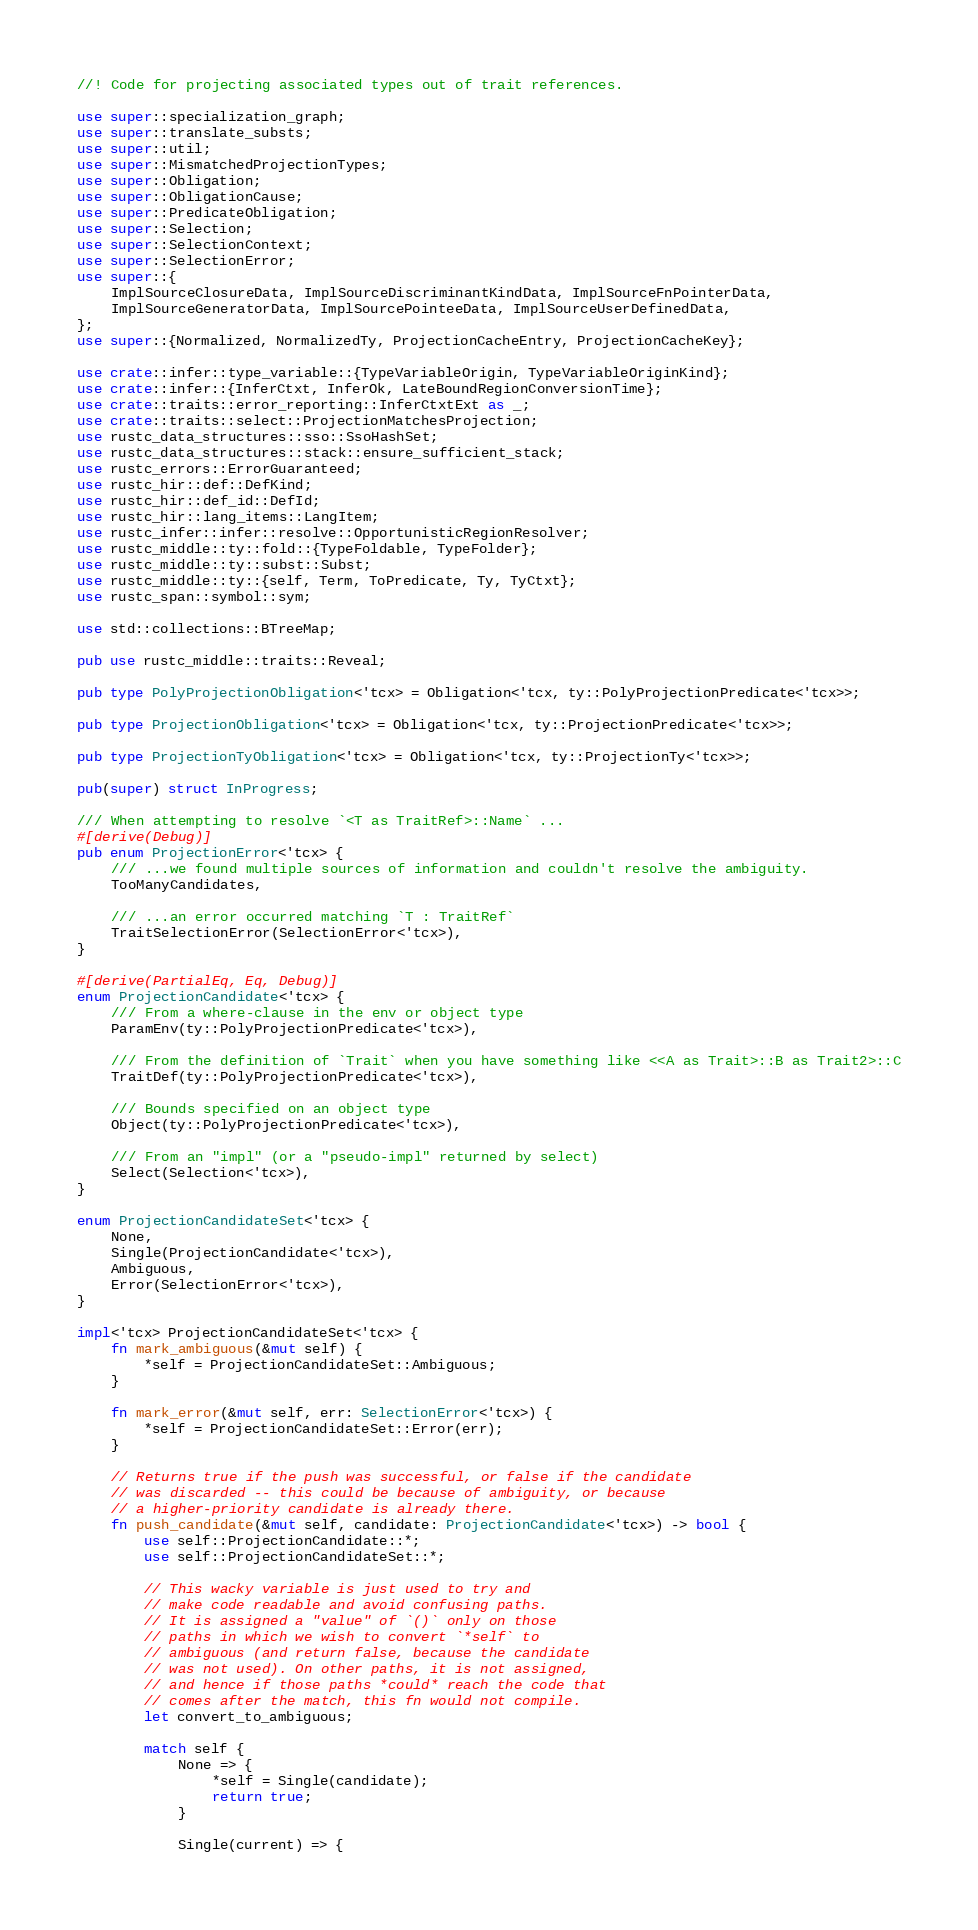<code> <loc_0><loc_0><loc_500><loc_500><_Rust_>//! Code for projecting associated types out of trait references.

use super::specialization_graph;
use super::translate_substs;
use super::util;
use super::MismatchedProjectionTypes;
use super::Obligation;
use super::ObligationCause;
use super::PredicateObligation;
use super::Selection;
use super::SelectionContext;
use super::SelectionError;
use super::{
    ImplSourceClosureData, ImplSourceDiscriminantKindData, ImplSourceFnPointerData,
    ImplSourceGeneratorData, ImplSourcePointeeData, ImplSourceUserDefinedData,
};
use super::{Normalized, NormalizedTy, ProjectionCacheEntry, ProjectionCacheKey};

use crate::infer::type_variable::{TypeVariableOrigin, TypeVariableOriginKind};
use crate::infer::{InferCtxt, InferOk, LateBoundRegionConversionTime};
use crate::traits::error_reporting::InferCtxtExt as _;
use crate::traits::select::ProjectionMatchesProjection;
use rustc_data_structures::sso::SsoHashSet;
use rustc_data_structures::stack::ensure_sufficient_stack;
use rustc_errors::ErrorGuaranteed;
use rustc_hir::def::DefKind;
use rustc_hir::def_id::DefId;
use rustc_hir::lang_items::LangItem;
use rustc_infer::infer::resolve::OpportunisticRegionResolver;
use rustc_middle::ty::fold::{TypeFoldable, TypeFolder};
use rustc_middle::ty::subst::Subst;
use rustc_middle::ty::{self, Term, ToPredicate, Ty, TyCtxt};
use rustc_span::symbol::sym;

use std::collections::BTreeMap;

pub use rustc_middle::traits::Reveal;

pub type PolyProjectionObligation<'tcx> = Obligation<'tcx, ty::PolyProjectionPredicate<'tcx>>;

pub type ProjectionObligation<'tcx> = Obligation<'tcx, ty::ProjectionPredicate<'tcx>>;

pub type ProjectionTyObligation<'tcx> = Obligation<'tcx, ty::ProjectionTy<'tcx>>;

pub(super) struct InProgress;

/// When attempting to resolve `<T as TraitRef>::Name` ...
#[derive(Debug)]
pub enum ProjectionError<'tcx> {
    /// ...we found multiple sources of information and couldn't resolve the ambiguity.
    TooManyCandidates,

    /// ...an error occurred matching `T : TraitRef`
    TraitSelectionError(SelectionError<'tcx>),
}

#[derive(PartialEq, Eq, Debug)]
enum ProjectionCandidate<'tcx> {
    /// From a where-clause in the env or object type
    ParamEnv(ty::PolyProjectionPredicate<'tcx>),

    /// From the definition of `Trait` when you have something like <<A as Trait>::B as Trait2>::C
    TraitDef(ty::PolyProjectionPredicate<'tcx>),

    /// Bounds specified on an object type
    Object(ty::PolyProjectionPredicate<'tcx>),

    /// From an "impl" (or a "pseudo-impl" returned by select)
    Select(Selection<'tcx>),
}

enum ProjectionCandidateSet<'tcx> {
    None,
    Single(ProjectionCandidate<'tcx>),
    Ambiguous,
    Error(SelectionError<'tcx>),
}

impl<'tcx> ProjectionCandidateSet<'tcx> {
    fn mark_ambiguous(&mut self) {
        *self = ProjectionCandidateSet::Ambiguous;
    }

    fn mark_error(&mut self, err: SelectionError<'tcx>) {
        *self = ProjectionCandidateSet::Error(err);
    }

    // Returns true if the push was successful, or false if the candidate
    // was discarded -- this could be because of ambiguity, or because
    // a higher-priority candidate is already there.
    fn push_candidate(&mut self, candidate: ProjectionCandidate<'tcx>) -> bool {
        use self::ProjectionCandidate::*;
        use self::ProjectionCandidateSet::*;

        // This wacky variable is just used to try and
        // make code readable and avoid confusing paths.
        // It is assigned a "value" of `()` only on those
        // paths in which we wish to convert `*self` to
        // ambiguous (and return false, because the candidate
        // was not used). On other paths, it is not assigned,
        // and hence if those paths *could* reach the code that
        // comes after the match, this fn would not compile.
        let convert_to_ambiguous;

        match self {
            None => {
                *self = Single(candidate);
                return true;
            }

            Single(current) => {</code> 